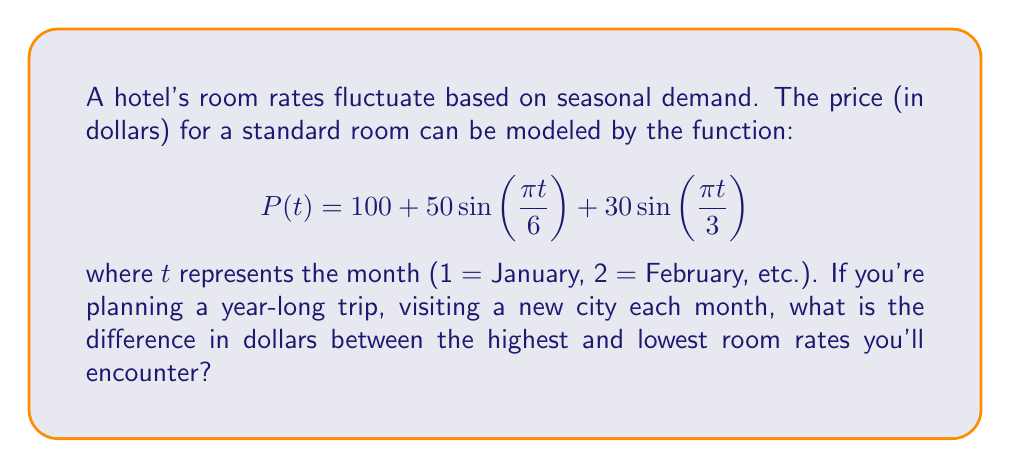Provide a solution to this math problem. To find the difference between the highest and lowest room rates, we need to:

1. Determine the maximum and minimum values of $P(t)$.
2. Calculate the difference between these values.

Step 1: Finding the extrema

The function $P(t)$ is periodic with a period of 12 months. To find the extrema, we can:
a) Find the derivative and set it to zero.
b) Evaluate the function at critical points and endpoints of the interval [1, 12].

The derivative is:
$$P'(t) = \frac{25\pi}{3}\cos\left(\frac{\pi t}{6}\right) + 10\pi\cos\left(\frac{\pi t}{3}\right)$$

Setting $P'(t) = 0$ is complex, so let's use method (b).

Evaluating $P(t)$ for $t = 1, 2, ..., 12$:

$P(1) \approx 179.90$
$P(2) \approx 150.00$
$P(3) \approx 120.10$
$P(4) \approx 100.00$
$P(5) \approx 100.00$
$P(6) \approx 120.10$
$P(7) \approx 150.00$
$P(8) \approx 179.90$
$P(9) \approx 200.00$
$P(10) \approx 200.00$
$P(11) \approx 179.90$
$P(12) \approx 150.00$

Step 2: Calculating the difference

The maximum value is $200.00 (months 9 and 10)
The minimum value is $100.00 (months 4 and 5)

The difference is: $200.00 - 100.00 = 100.00$
Answer: $100 